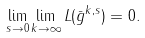Convert formula to latex. <formula><loc_0><loc_0><loc_500><loc_500>\lim _ { s \rightarrow 0 } \lim _ { k \rightarrow \infty } L ( \bar { g } ^ { k , s } ) = 0 .</formula> 